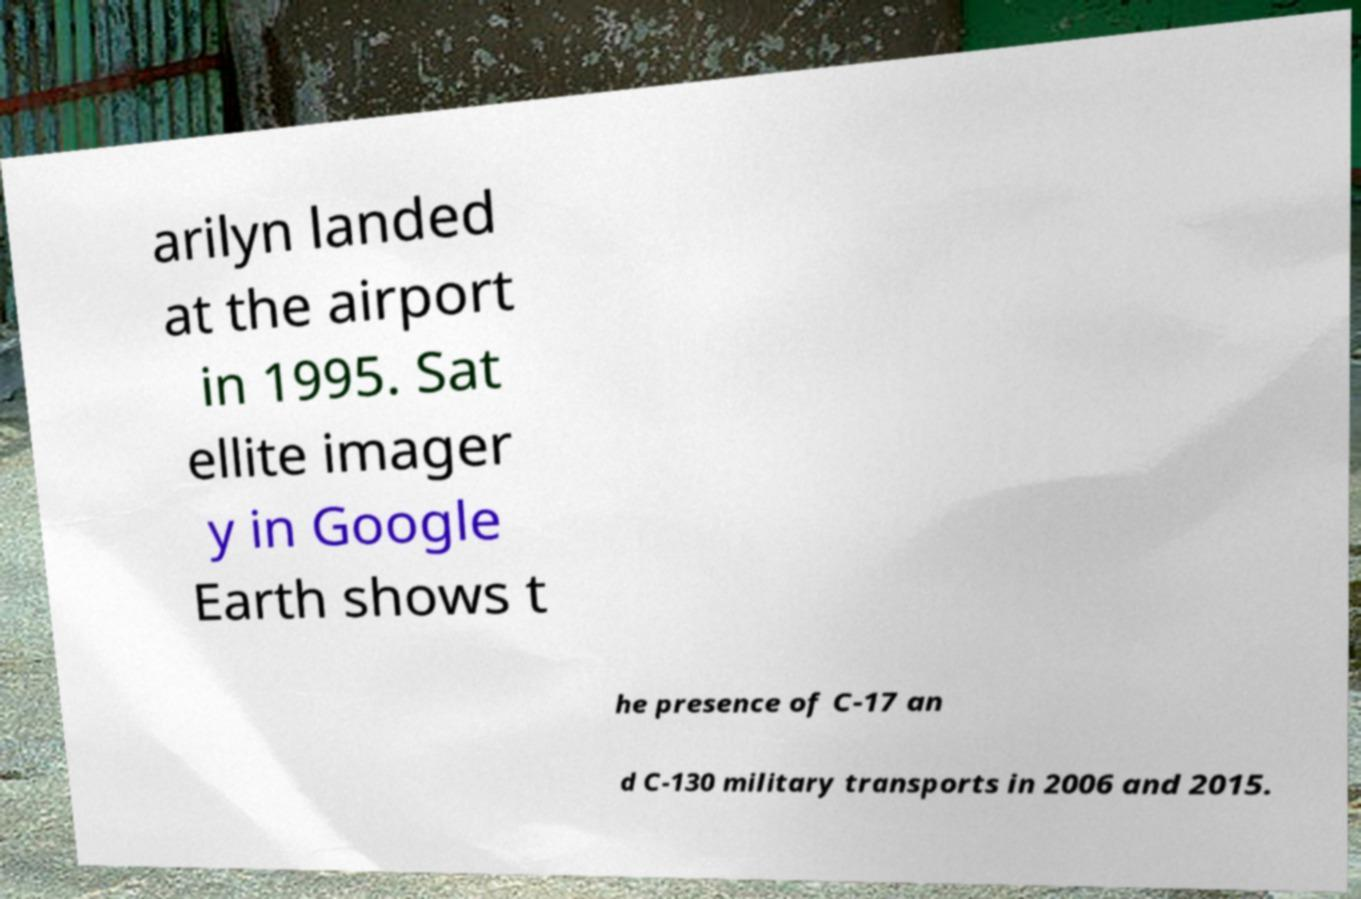Could you extract and type out the text from this image? arilyn landed at the airport in 1995. Sat ellite imager y in Google Earth shows t he presence of C-17 an d C-130 military transports in 2006 and 2015. 